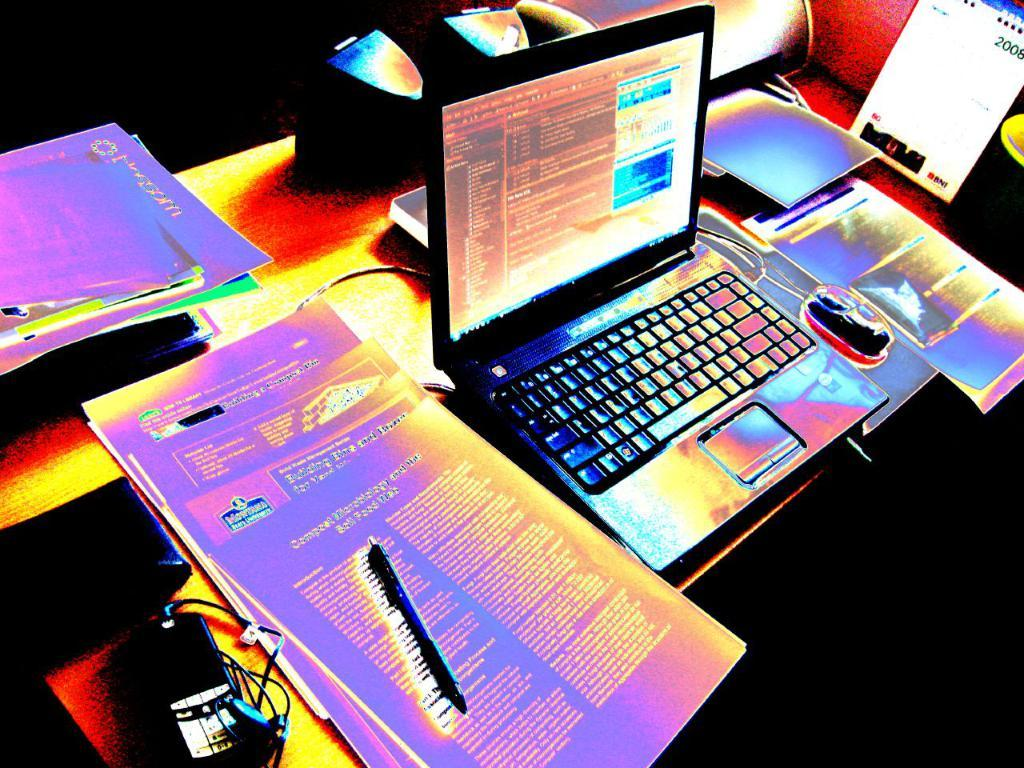<image>
Create a compact narrative representing the image presented. A table with paperwork and a laptop with a phone screen reading 2008 standing beside the computer mouse 